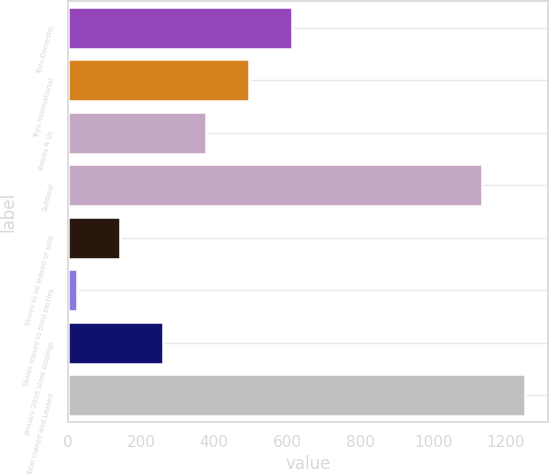Convert chart to OTSL. <chart><loc_0><loc_0><loc_500><loc_500><bar_chart><fcel>Toys-Domestic<fcel>Toys-International<fcel>Babies R Us<fcel>Subtotal<fcel>Stores to be leased or sold<fcel>Stores leased to third parties<fcel>January 2006 store closings<fcel>Total Owned and Leased<nl><fcel>614.5<fcel>496.6<fcel>378.7<fcel>1135<fcel>142.9<fcel>25<fcel>260.8<fcel>1252.9<nl></chart> 